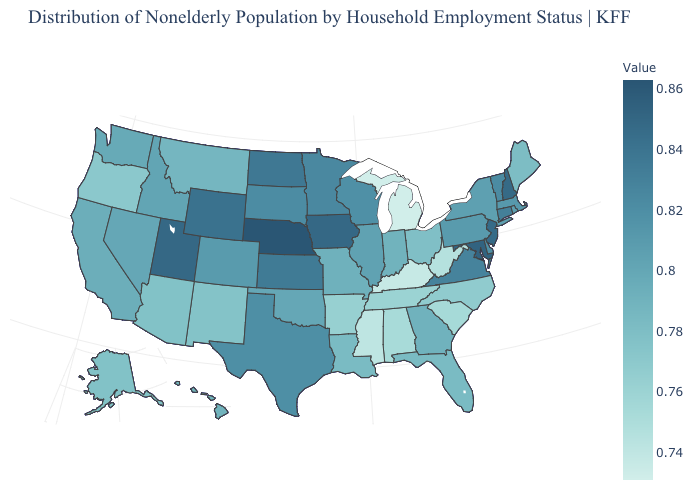Among the states that border Wyoming , which have the highest value?
Give a very brief answer. Nebraska. Among the states that border Nevada , which have the highest value?
Short answer required. Utah. Is the legend a continuous bar?
Be succinct. Yes. Is the legend a continuous bar?
Answer briefly. Yes. Which states have the lowest value in the South?
Concise answer only. Kentucky. Among the states that border Texas , which have the highest value?
Quick response, please. Oklahoma. Which states have the lowest value in the USA?
Give a very brief answer. Michigan. 